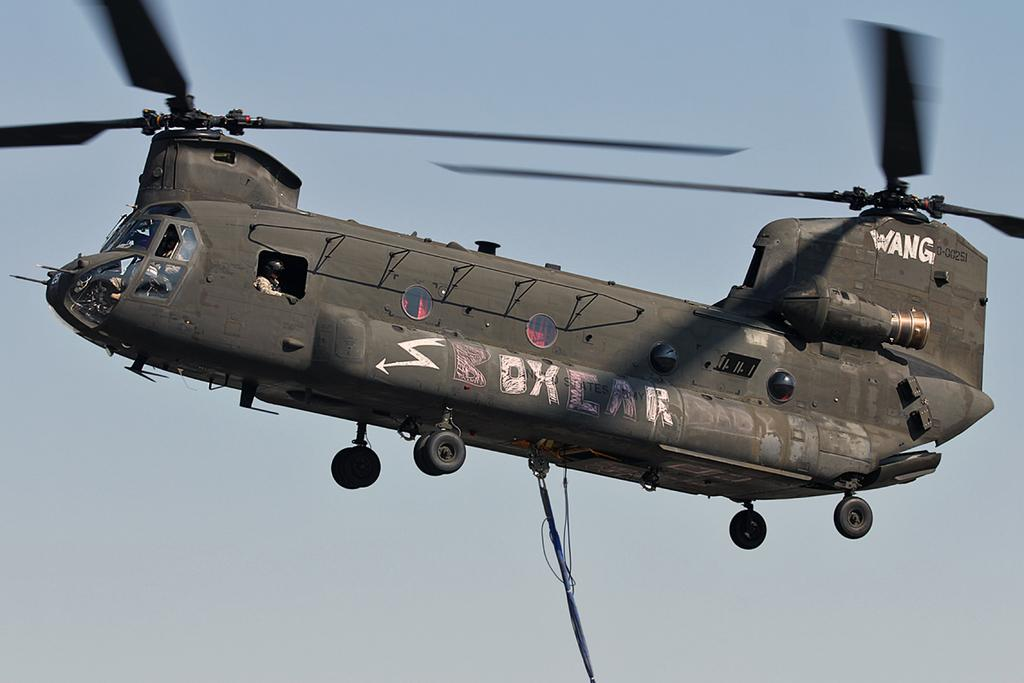<image>
Write a terse but informative summary of the picture. Military aircraft with with and pink chalk writing that says Boxcar baby and wang. 